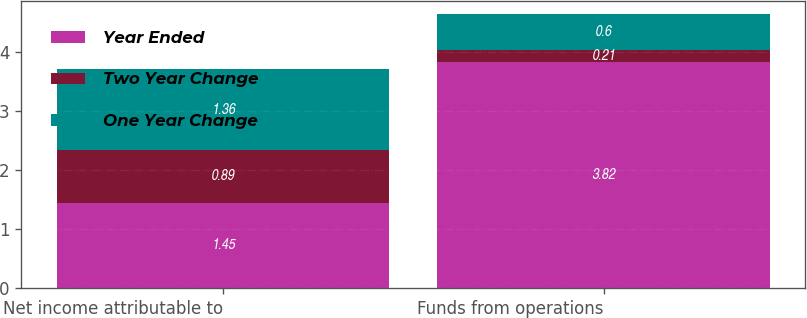Convert chart to OTSL. <chart><loc_0><loc_0><loc_500><loc_500><stacked_bar_chart><ecel><fcel>Net income attributable to<fcel>Funds from operations<nl><fcel>Year Ended<fcel>1.45<fcel>3.82<nl><fcel>Two Year Change<fcel>0.89<fcel>0.21<nl><fcel>One Year Change<fcel>1.36<fcel>0.6<nl></chart> 